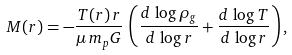Convert formula to latex. <formula><loc_0><loc_0><loc_500><loc_500>M ( r ) = - \frac { T ( r ) \, r } { \mu \, m _ { p } G } \, \left ( \frac { d \, \log \rho _ { g } } { d \, \log r } + \frac { d \, \log T } { d \, \log r } \right ) ,</formula> 